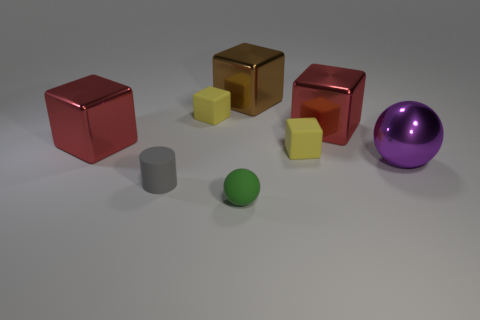Subtract all matte blocks. How many blocks are left? 3 Add 1 red metal things. How many objects exist? 9 Subtract all green balls. How many balls are left? 1 Subtract 2 blocks. How many blocks are left? 3 Subtract all yellow balls. Subtract all cyan cylinders. How many balls are left? 2 Subtract all big spheres. Subtract all large shiny blocks. How many objects are left? 4 Add 2 large red objects. How many large red objects are left? 4 Add 4 large brown blocks. How many large brown blocks exist? 5 Subtract 1 purple spheres. How many objects are left? 7 Subtract all cylinders. How many objects are left? 7 